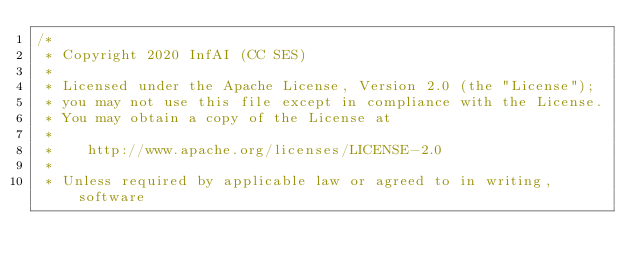<code> <loc_0><loc_0><loc_500><loc_500><_Go_>/*
 * Copyright 2020 InfAI (CC SES)
 *
 * Licensed under the Apache License, Version 2.0 (the "License");
 * you may not use this file except in compliance with the License.
 * You may obtain a copy of the License at
 *
 *    http://www.apache.org/licenses/LICENSE-2.0
 *
 * Unless required by applicable law or agreed to in writing, software</code> 